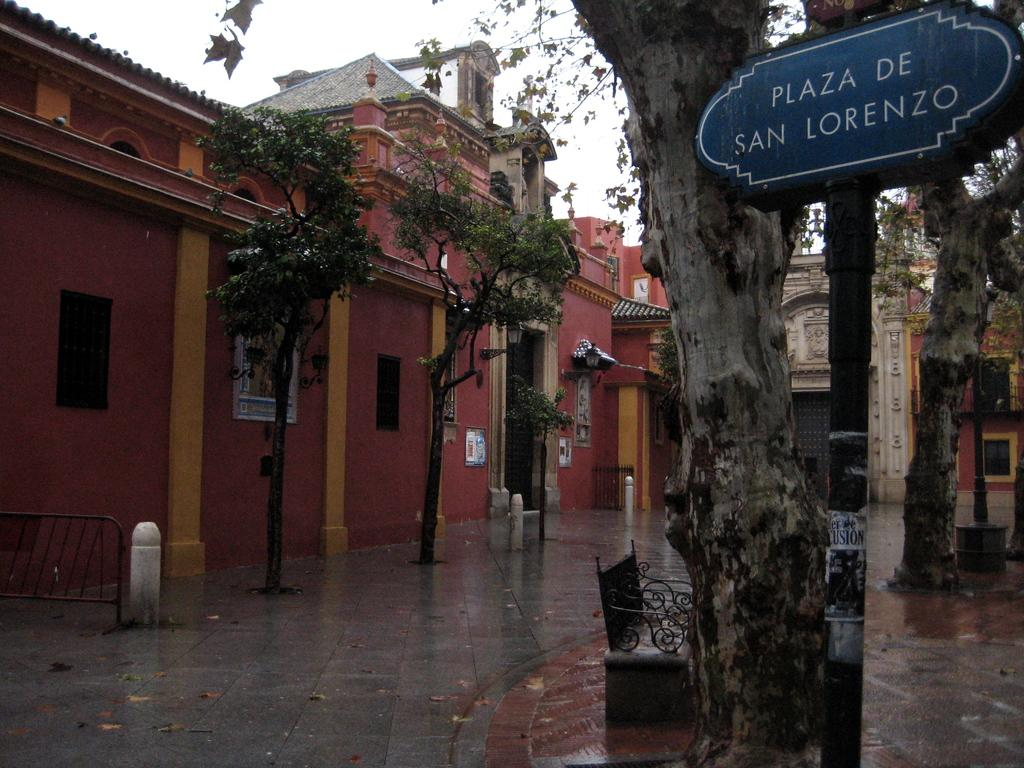<image>
Give a short and clear explanation of the subsequent image. A wet street scene with a sign reading Plaza De San Lorenzo 